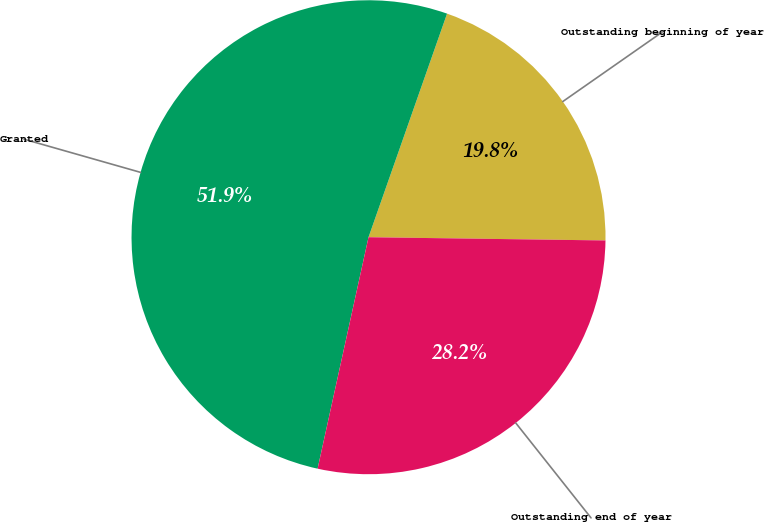Convert chart to OTSL. <chart><loc_0><loc_0><loc_500><loc_500><pie_chart><fcel>Outstanding beginning of year<fcel>Granted<fcel>Outstanding end of year<nl><fcel>19.84%<fcel>51.93%<fcel>28.23%<nl></chart> 